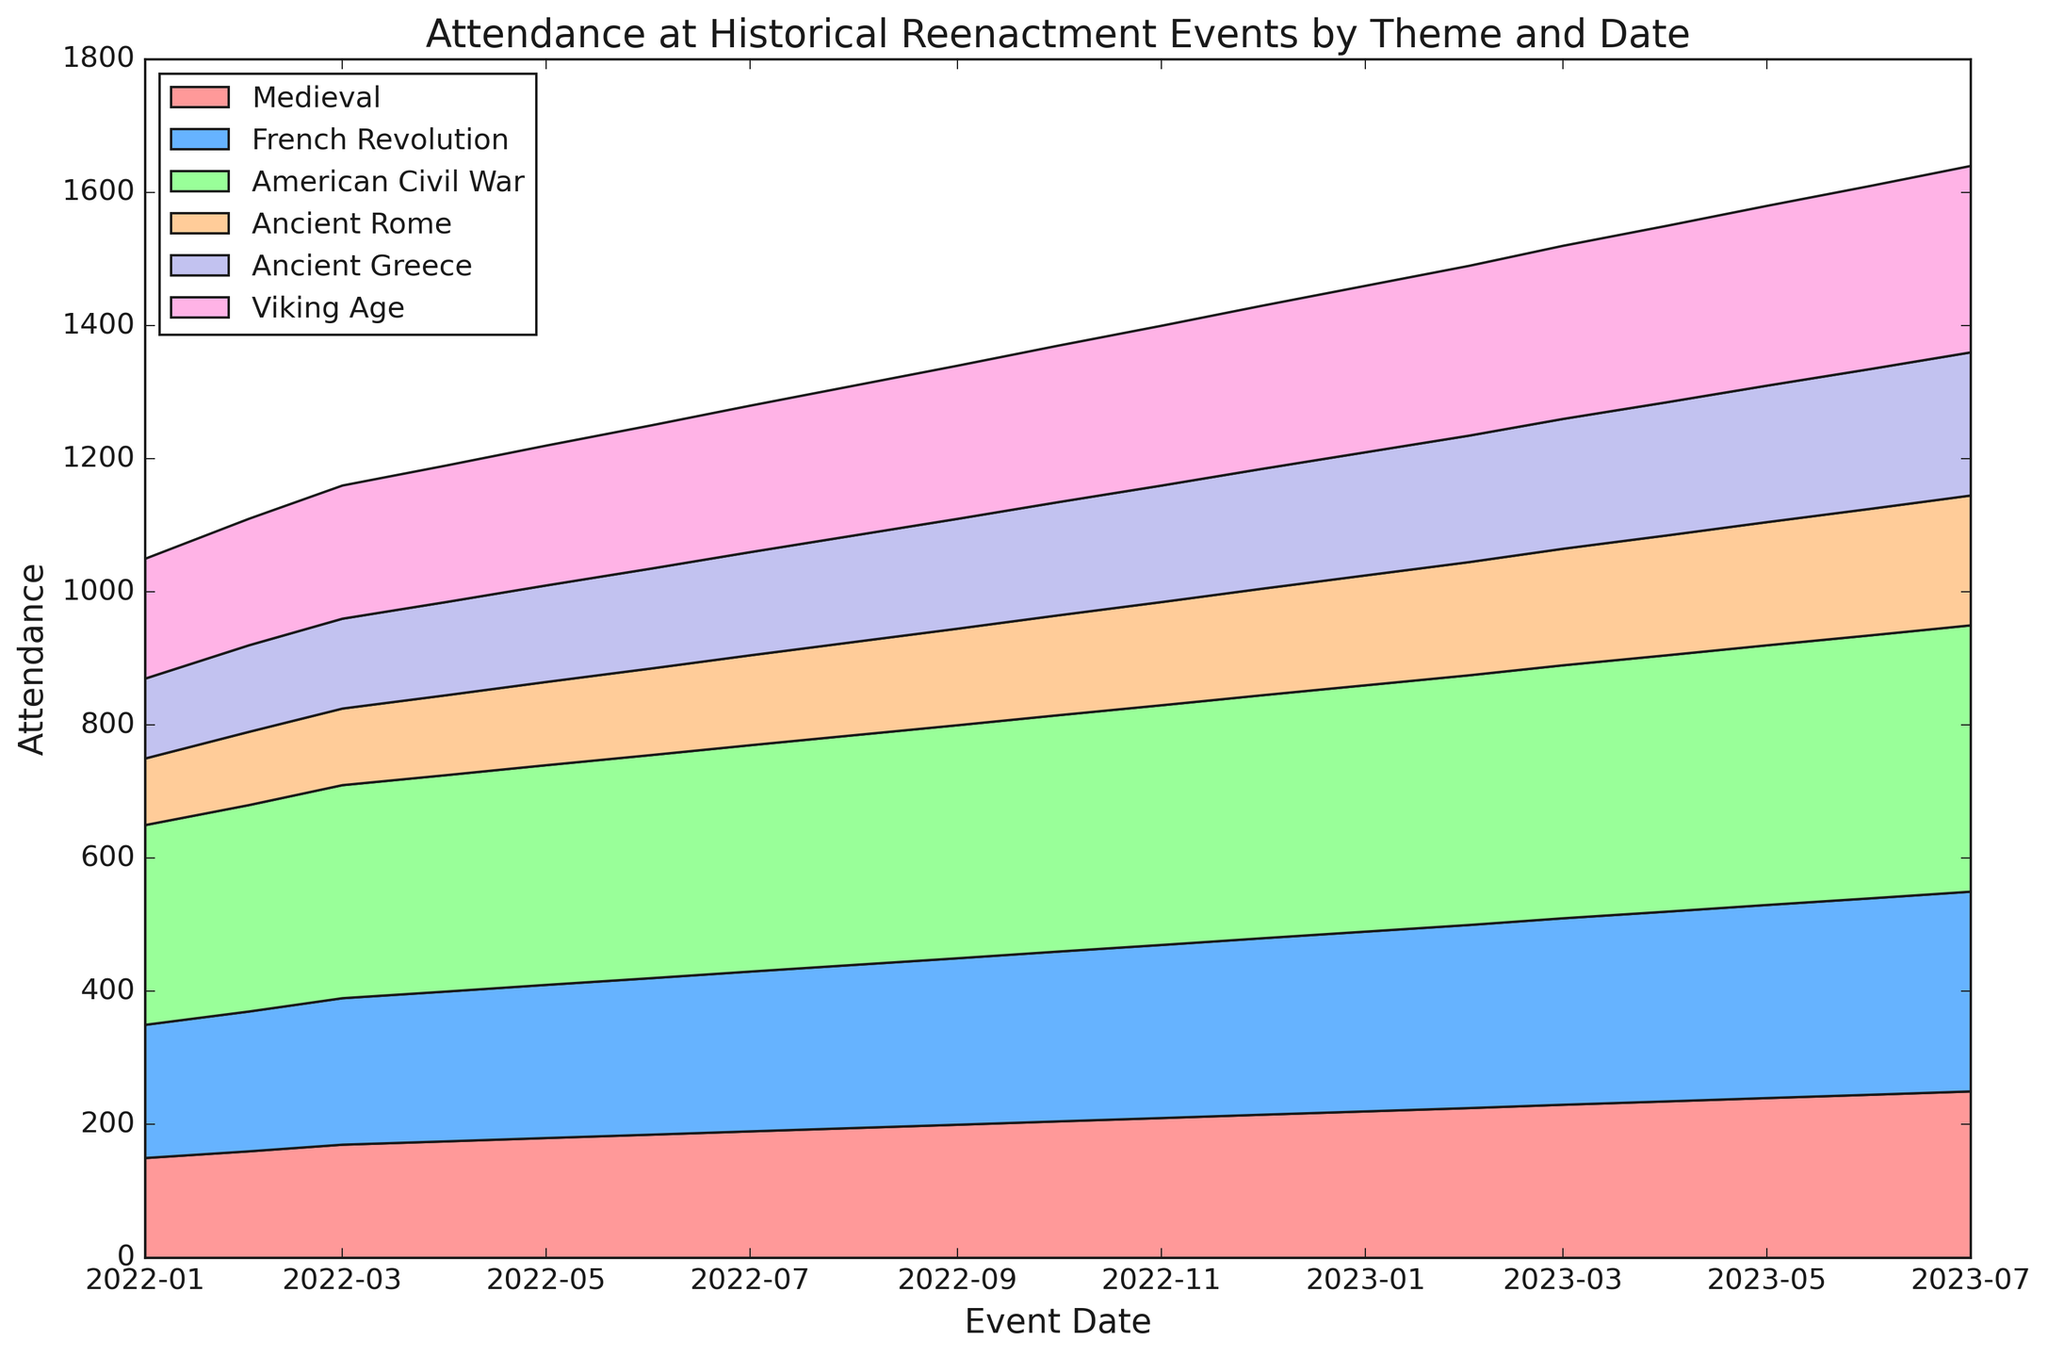Which theme had the highest attendance in July 2023? Look for July 2023 on the x-axis and compare the heights of the different colors. The tallest color segment represents the attendance of the American Civil War.
Answer: American Civil War How did attendance for Medieval events change from January 2022 to July 2023? Compare the height of the Medieval segment (typically the bottommost layer) at the two dates. It starts at 150 in January 2022 and increases steadily to 250 by July 2023.
Answer: Increased What is the total attendance for all themes combined in December 2022? Sum up the individual attendance numbers for each theme in December 2022: 215 (Medieval) + 265 (French Revolution) + 365 (American Civil War) + 160 (Ancient Rome) + 180 (Ancient Greece) + 245 (Viking Age) = 1430.
Answer: 1430 Which theme saw the least growth in attendance over the entire period? Compare the differences in attendance from January 2022 to July 2023 for all themes. Medieval increased from 150 to 250, French Revolution from 200 to 300, American Civil War from 300 to 400, Ancient Rome from 100 to 195, Ancient Greece from 120 to 215, and Viking Age from 180 to 280. Ancient Rome had the smallest absolute increase (195 - 100 = 95).
Answer: Ancient Rome How does the attendance at Viking Age events in November 2022 compare to February 2023? Look at the height of the Viking Age color segment for both dates. In November 2022, attendance is 240, and in February 2023, it is 255. Subtract the two: 255 - 240 = 15.
Answer: Increased by 15 What month saw the largest single-month increase in attendance for Ancient Greece events? Analyze the height changes for Ancient Greece month by month. February 2023 to March 2023 shows the largest increase: from 190 to 195 (an increase of 5).
Answer: March 2023 Which event category consistently had an attendance higher than 300 after July 2022? Compare and see which segment has been above the 300 mark post-July 2022. The American Civil War segment remains consistently above 300.
Answer: American Civil War What is the average attendance for the French Revolution events over the entire period? Sum up all the French Revolution attendance numbers and then divide by the total number of records (18): (200 + 210 + 220 + 225 + 230 + 235 + 240 + 245 + 250 + 255 + 260 + 265 + 270 + 275 + 280 + 285 + 290 + 295 + 300) = 4810. Average = 4810 / 18 ≈ 267.22.
Answer: 267.22 How do the attendance numbers for Medieval events in April 2022 compare to those in April 2023? Compare the heights of the Medieval segment in the two months. April 2022 has an attendance of 175, and April 2023 has 235. The difference is 235 - 175 = 60.
Answer: Increased by 60 